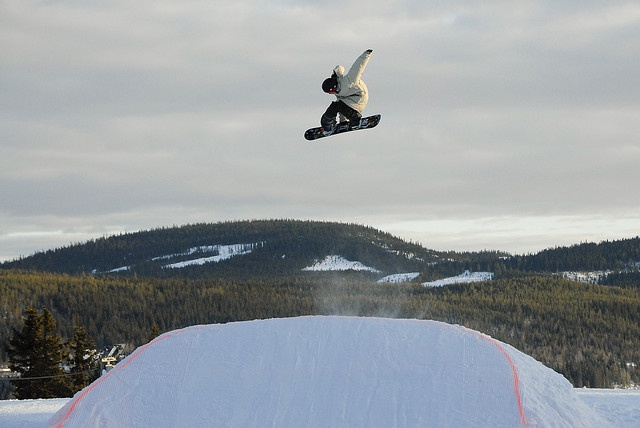Describe the objects in this image and their specific colors. I can see people in darkgray, black, gray, and tan tones and snowboard in darkgray, black, and gray tones in this image. 